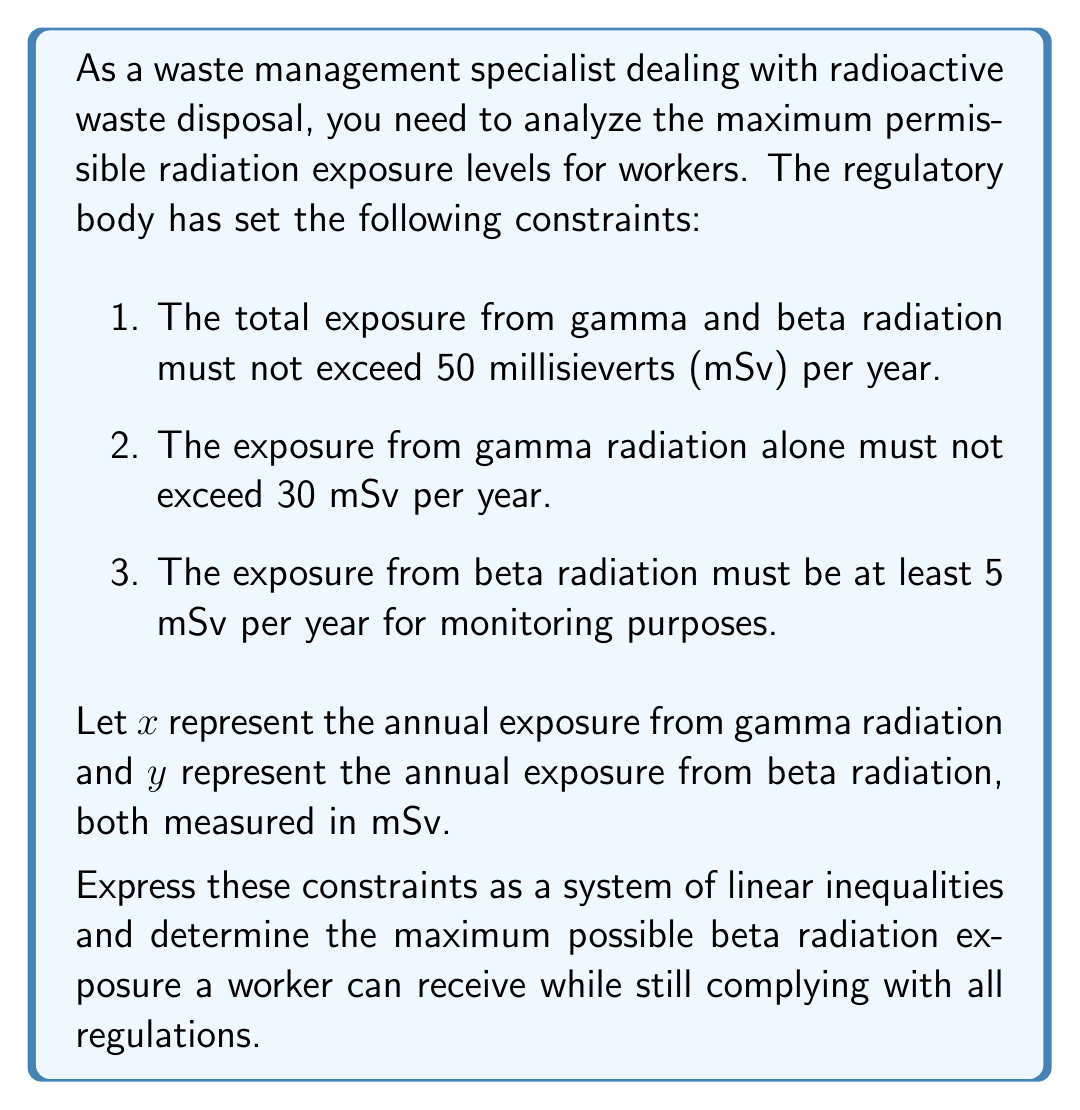Solve this math problem. To solve this problem, we'll follow these steps:

1. Express the constraints as linear inequalities:
   a. Total exposure limit: $x + y \leq 50$
   b. Gamma radiation limit: $x \leq 30$
   c. Minimum beta radiation: $y \geq 5$
   d. Non-negativity constraints: $x \geq 0$ and $y \geq 0$

2. Visualize the feasible region:
   The feasible region is bounded by these inequalities. The maximum beta radiation exposure will occur at one of the vertices of this region.

3. Find the vertices of the feasible region:
   - Point A: Intersection of $x = 0$ and $y = 5$: $(0, 5)$
   - Point B: Intersection of $x = 30$ and $y = 5$: $(30, 5)$
   - Point C: Intersection of $x = 30$ and $x + y = 50$: $(30, 20)$

4. Evaluate the $y$-coordinate (beta radiation exposure) at each vertex:
   - Point A: $y = 5$
   - Point B: $y = 5$
   - Point C: $y = 20$

The maximum $y$ value among these points is 20, which occurs at point C.
Answer: The maximum possible beta radiation exposure a worker can receive while complying with all regulations is 20 mSv per year. 